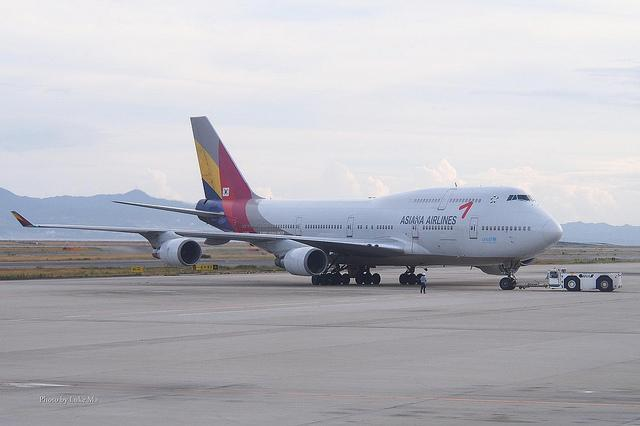This vehicle is most likely from? Please explain your reasoning. south korea. The plane says it's from asia. 